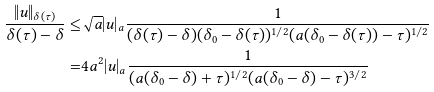Convert formula to latex. <formula><loc_0><loc_0><loc_500><loc_500>\frac { \| u \| _ { \delta ( \tau ) } } { \delta ( \tau ) - \delta } \leq & \sqrt { a } | u | _ { a } \frac { 1 } { ( \delta ( \tau ) - \delta ) ( \delta _ { 0 } - \delta ( \tau ) ) ^ { 1 / 2 } ( a ( \delta _ { 0 } - \delta ( \tau ) ) - \tau ) ^ { 1 / 2 } } \\ = & 4 a ^ { 2 } | u | _ { a } \frac { 1 } { ( a ( \delta _ { 0 } - \delta ) + \tau ) ^ { 1 / 2 } ( a ( \delta _ { 0 } - \delta ) - \tau ) ^ { 3 / 2 } }</formula> 